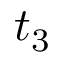Convert formula to latex. <formula><loc_0><loc_0><loc_500><loc_500>t _ { 3 }</formula> 